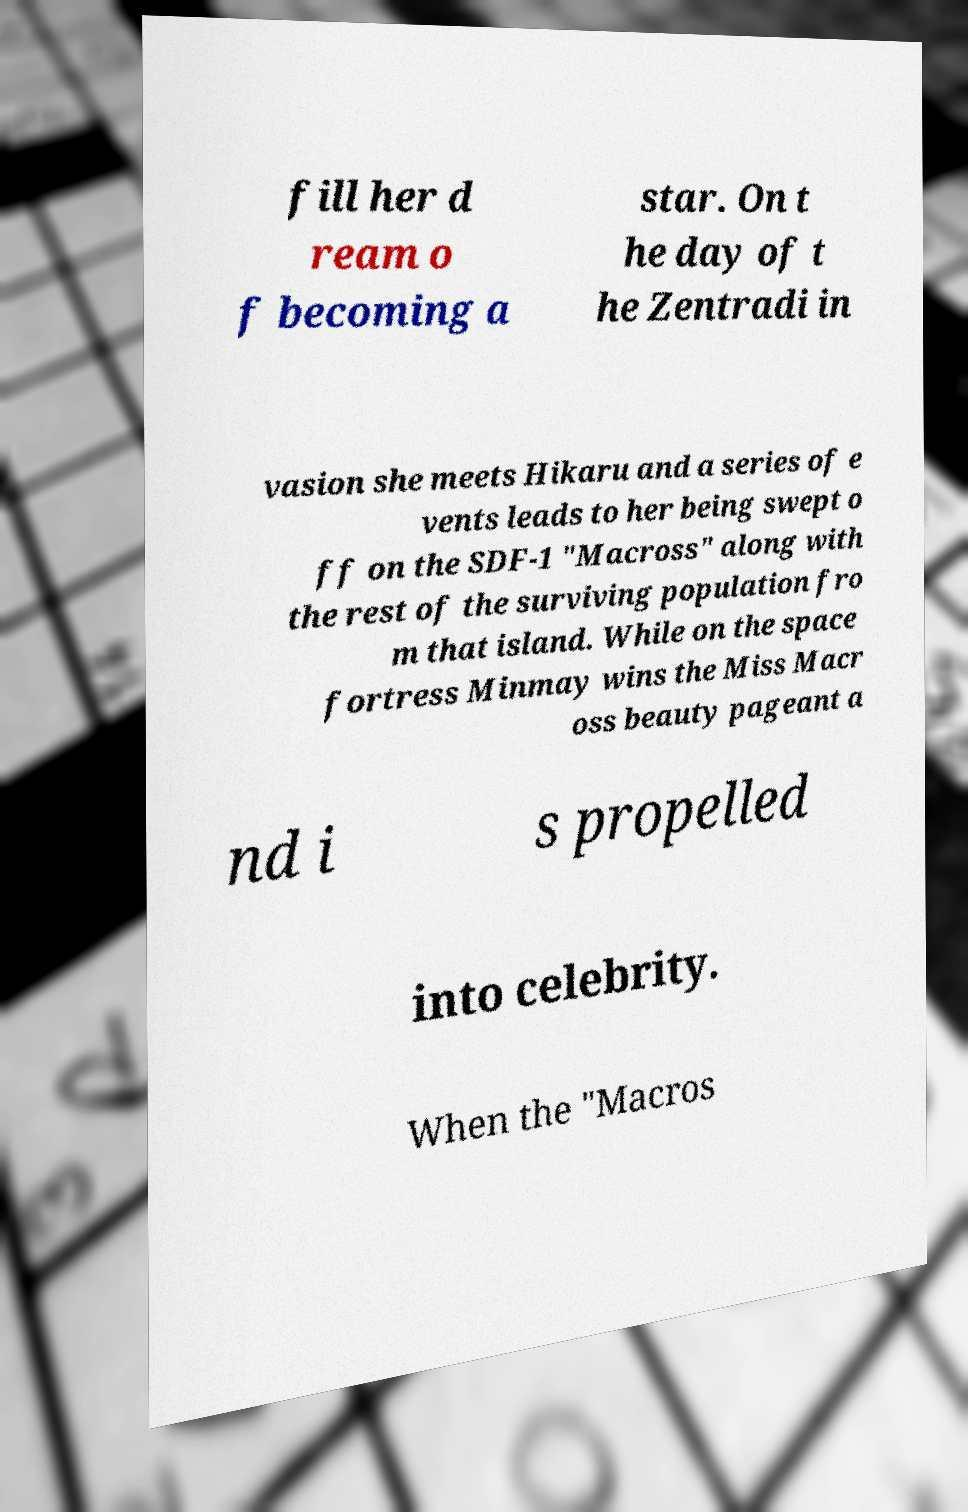Please read and relay the text visible in this image. What does it say? fill her d ream o f becoming a star. On t he day of t he Zentradi in vasion she meets Hikaru and a series of e vents leads to her being swept o ff on the SDF-1 "Macross" along with the rest of the surviving population fro m that island. While on the space fortress Minmay wins the Miss Macr oss beauty pageant a nd i s propelled into celebrity. When the "Macros 